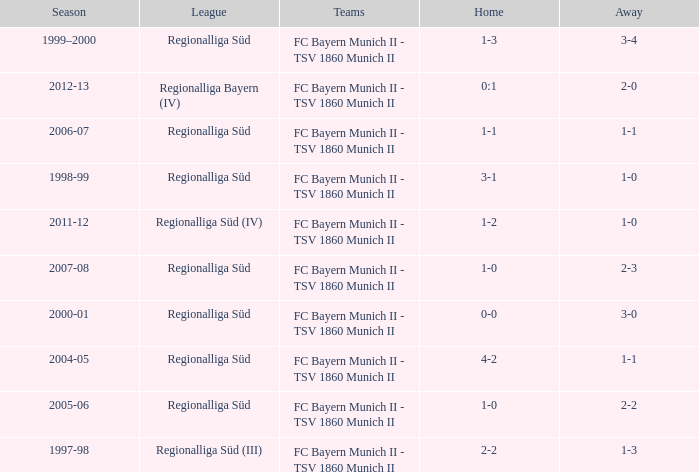I'm looking to parse the entire table for insights. Could you assist me with that? {'header': ['Season', 'League', 'Teams', 'Home', 'Away'], 'rows': [['1999–2000', 'Regionalliga Süd', 'FC Bayern Munich II - TSV 1860 Munich II', '1-3', '3-4'], ['2012-13', 'Regionalliga Bayern (IV)', 'FC Bayern Munich II - TSV 1860 Munich II', '0:1', '2-0'], ['2006-07', 'Regionalliga Süd', 'FC Bayern Munich II - TSV 1860 Munich II', '1-1', '1-1'], ['1998-99', 'Regionalliga Süd', 'FC Bayern Munich II - TSV 1860 Munich II', '3-1', '1-0'], ['2011-12', 'Regionalliga Süd (IV)', 'FC Bayern Munich II - TSV 1860 Munich II', '1-2', '1-0'], ['2007-08', 'Regionalliga Süd', 'FC Bayern Munich II - TSV 1860 Munich II', '1-0', '2-3'], ['2000-01', 'Regionalliga Süd', 'FC Bayern Munich II - TSV 1860 Munich II', '0-0', '3-0'], ['2004-05', 'Regionalliga Süd', 'FC Bayern Munich II - TSV 1860 Munich II', '4-2', '1-1'], ['2005-06', 'Regionalliga Süd', 'FC Bayern Munich II - TSV 1860 Munich II', '1-0', '2-2'], ['1997-98', 'Regionalliga Süd (III)', 'FC Bayern Munich II - TSV 1860 Munich II', '2-2', '1-3']]} Which teams were in the 2006-07 season? FC Bayern Munich II - TSV 1860 Munich II. 